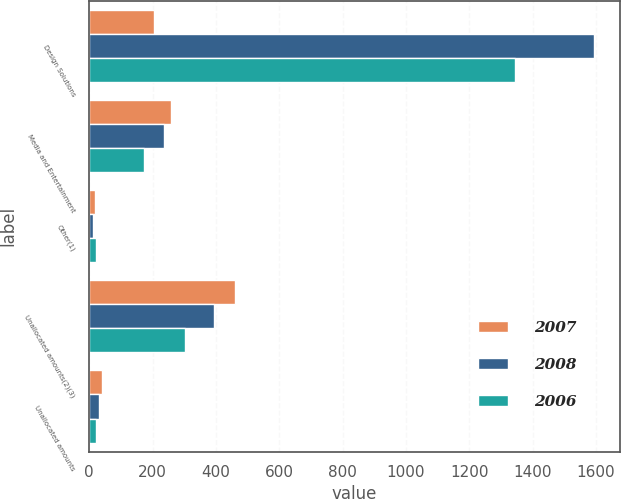Convert chart. <chart><loc_0><loc_0><loc_500><loc_500><stacked_bar_chart><ecel><fcel>Design Solutions<fcel>Media and Entertainment<fcel>Other(1)<fcel>Unallocated amounts(2)(3)<fcel>Unallocated amounts<nl><fcel>2007<fcel>203.45<fcel>258.6<fcel>18.2<fcel>459<fcel>39.6<nl><fcel>2008<fcel>1594.6<fcel>234.6<fcel>10.6<fcel>394.2<fcel>32.2<nl><fcel>2006<fcel>1344.5<fcel>172.3<fcel>20.4<fcel>301.1<fcel>22.4<nl></chart> 